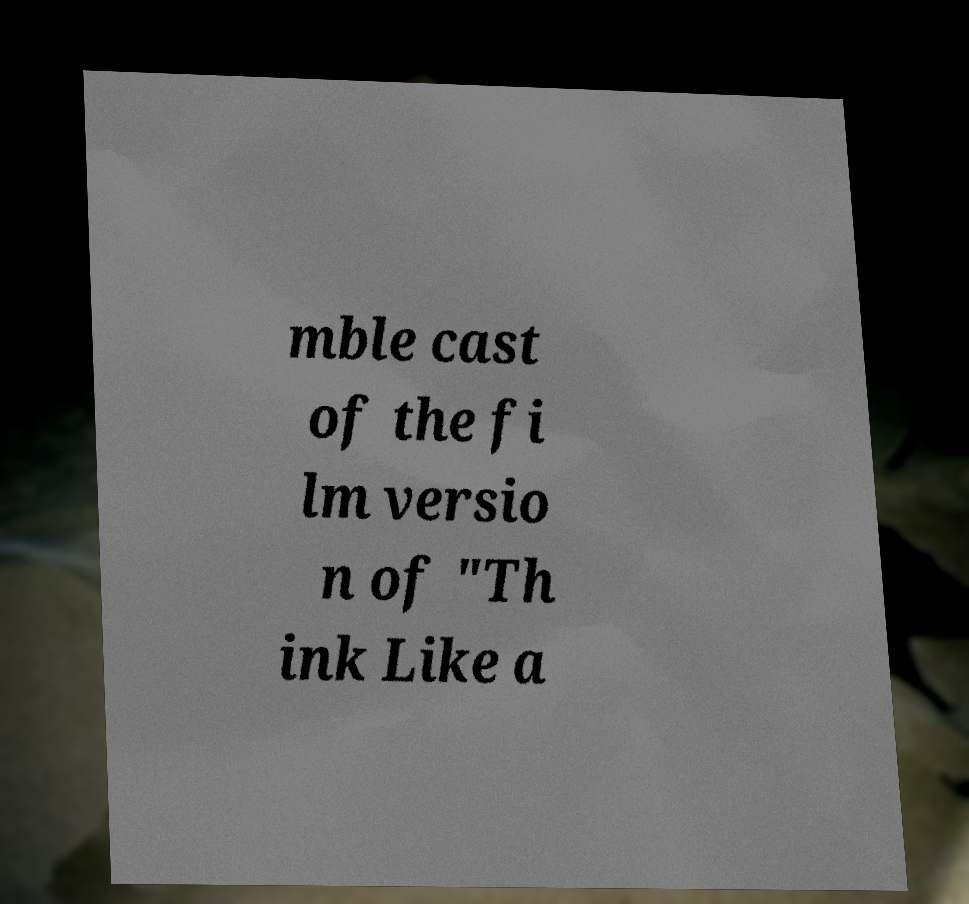For documentation purposes, I need the text within this image transcribed. Could you provide that? mble cast of the fi lm versio n of "Th ink Like a 